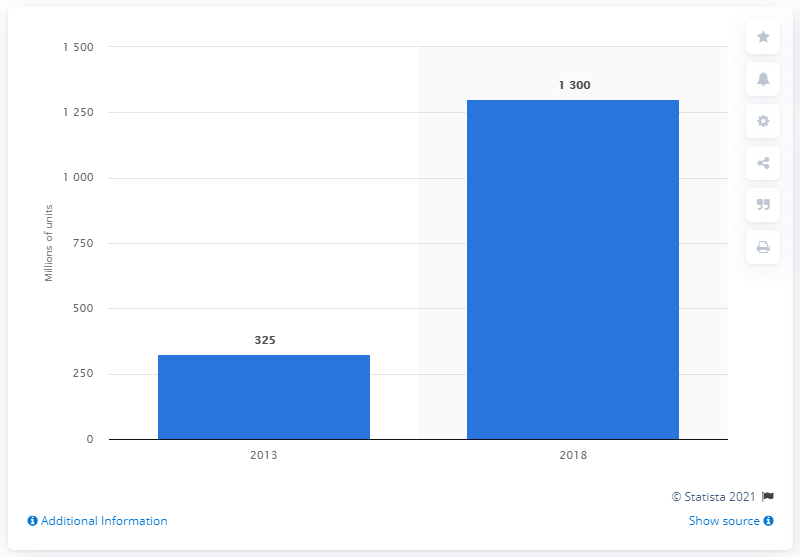Draw attention to some important aspects in this diagram. There is a forecast for the installation of security software on mobile devices in 2018. 